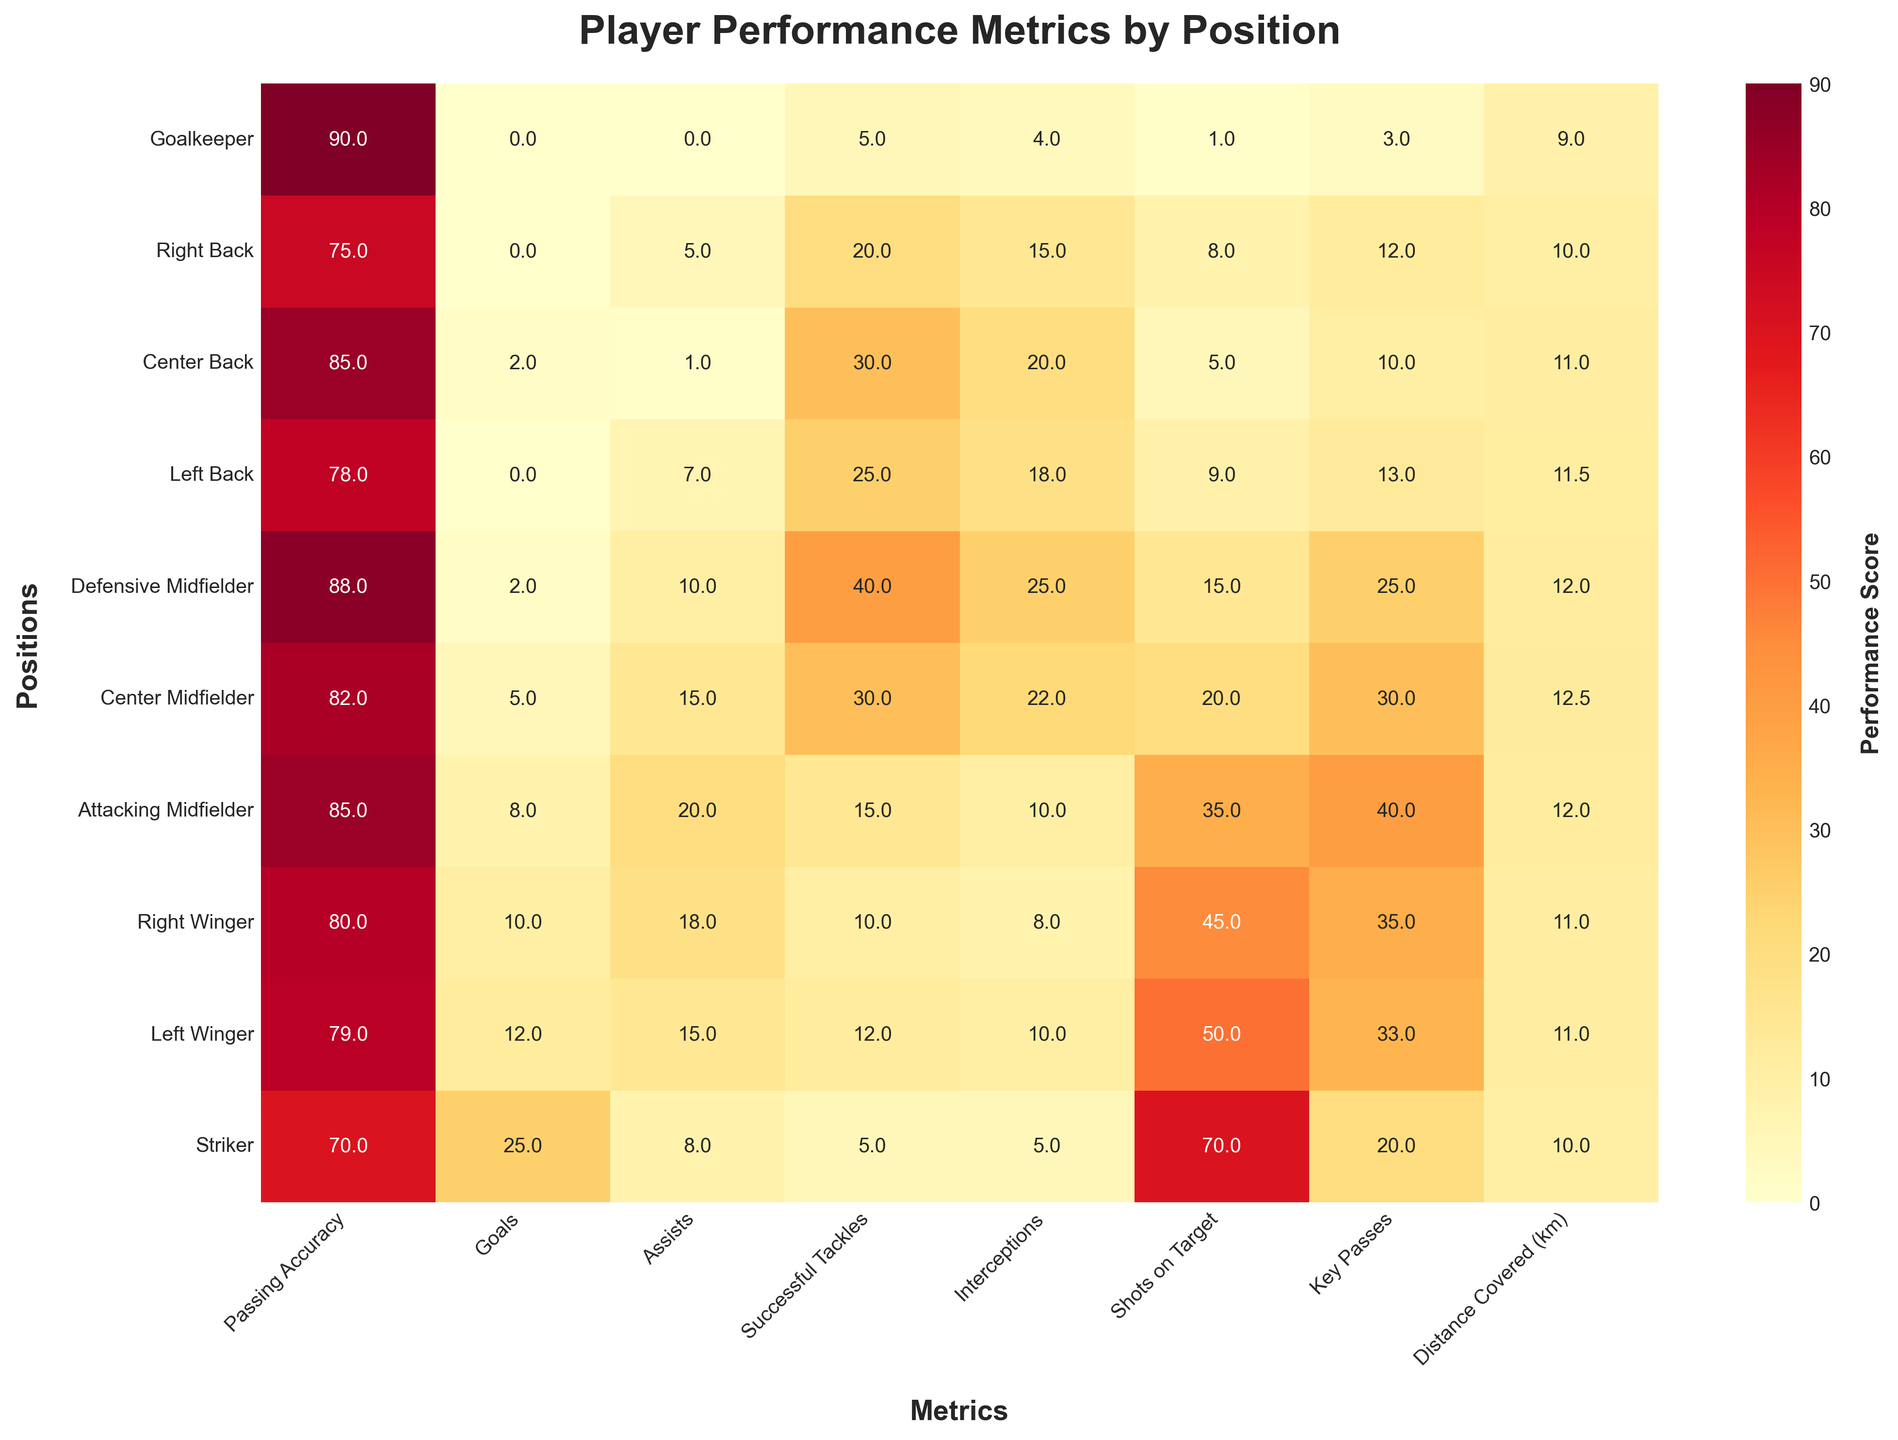what is the title of the heatmap? The title of the heatmap is "Player Performance Metrics by Position," which is typically displayed at the top center of the plot.
Answer: Player Performance Metrics by Position Which two positions have the highest passing accuracy? To determine the highest passing accuracy, you need to look at the column "Passing Accuracy" and identify the two positions with the highest values. Both the Goalkeeper and Defensive Midfielder have the highest accuracy with 90 and 88 respectively.
Answer: Goalkeeper, Defensive Midfielder How many goals did the Center Midfielder score? You can find this information in the "Goals" column for the Center Midfielder row, where it shows a value of 5.
Answer: 5 Which position has the lowest number of successful tackles? By checking the "Successful Tackles" column, the Striker has the lowest value with 5.
Answer: Striker What is the total number of assists made by the Left Back and the Right Winger? Check the "Assists" column and add the values for the Left Back (7) and the Right Winger (18). The total is 7 + 18 = 25.
Answer: 25 What is the average distance covered by the players? To find the average distance covered, add up the values in the "Distance Covered (km)" column and divide by the number of positions: (9 + 10 + 11 + 11.5 + 12 + 12.5 + 12 + 11 + 11 + 10) / 10 = (110)/10 = 11
Answer: 11 Which position has more goals, the Right Winger or the Left Winger? Compare the "Goals" column for the Right Winger (10) and the Left Winger (12). The Left Winger has more goals.
Answer: Left Winger Who has more interceptions, the Center Back or the Defensive Midfielder? Compare the "Interceptions" column for Center Back (20) and Defensive Midfielder (25). The Defensive Midfielder has more interceptions.
Answer: Defensive Midfielder Which position has the highest number of key passes? Look at the "Key Passes" column, where the Attacking Midfielder has the highest value with 40.
Answer: Attacking Midfielder What is the difference between the total number of goals scored by the Striker and the Defensive Midfielder? Check the "Goals" column for both positions: Striker (25) and Defensive Midfielder (2). The difference is 25 - 2 = 23.
Answer: 23 